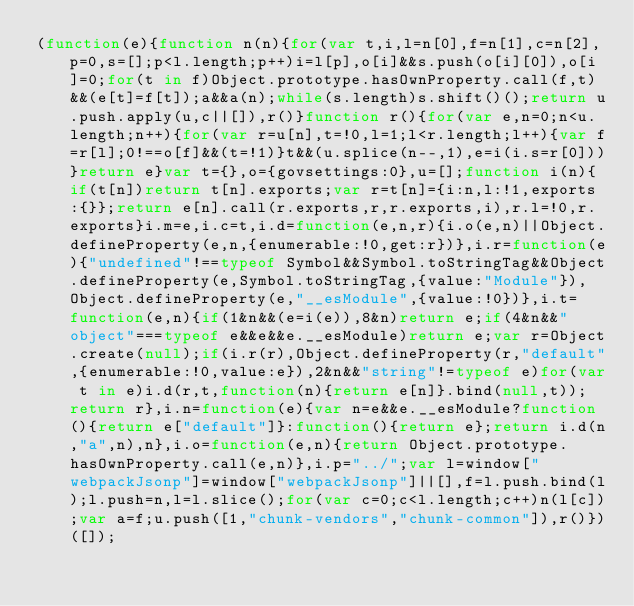Convert code to text. <code><loc_0><loc_0><loc_500><loc_500><_JavaScript_>(function(e){function n(n){for(var t,i,l=n[0],f=n[1],c=n[2],p=0,s=[];p<l.length;p++)i=l[p],o[i]&&s.push(o[i][0]),o[i]=0;for(t in f)Object.prototype.hasOwnProperty.call(f,t)&&(e[t]=f[t]);a&&a(n);while(s.length)s.shift()();return u.push.apply(u,c||[]),r()}function r(){for(var e,n=0;n<u.length;n++){for(var r=u[n],t=!0,l=1;l<r.length;l++){var f=r[l];0!==o[f]&&(t=!1)}t&&(u.splice(n--,1),e=i(i.s=r[0]))}return e}var t={},o={govsettings:0},u=[];function i(n){if(t[n])return t[n].exports;var r=t[n]={i:n,l:!1,exports:{}};return e[n].call(r.exports,r,r.exports,i),r.l=!0,r.exports}i.m=e,i.c=t,i.d=function(e,n,r){i.o(e,n)||Object.defineProperty(e,n,{enumerable:!0,get:r})},i.r=function(e){"undefined"!==typeof Symbol&&Symbol.toStringTag&&Object.defineProperty(e,Symbol.toStringTag,{value:"Module"}),Object.defineProperty(e,"__esModule",{value:!0})},i.t=function(e,n){if(1&n&&(e=i(e)),8&n)return e;if(4&n&&"object"===typeof e&&e&&e.__esModule)return e;var r=Object.create(null);if(i.r(r),Object.defineProperty(r,"default",{enumerable:!0,value:e}),2&n&&"string"!=typeof e)for(var t in e)i.d(r,t,function(n){return e[n]}.bind(null,t));return r},i.n=function(e){var n=e&&e.__esModule?function(){return e["default"]}:function(){return e};return i.d(n,"a",n),n},i.o=function(e,n){return Object.prototype.hasOwnProperty.call(e,n)},i.p="../";var l=window["webpackJsonp"]=window["webpackJsonp"]||[],f=l.push.bind(l);l.push=n,l=l.slice();for(var c=0;c<l.length;c++)n(l[c]);var a=f;u.push([1,"chunk-vendors","chunk-common"]),r()})([]);</code> 